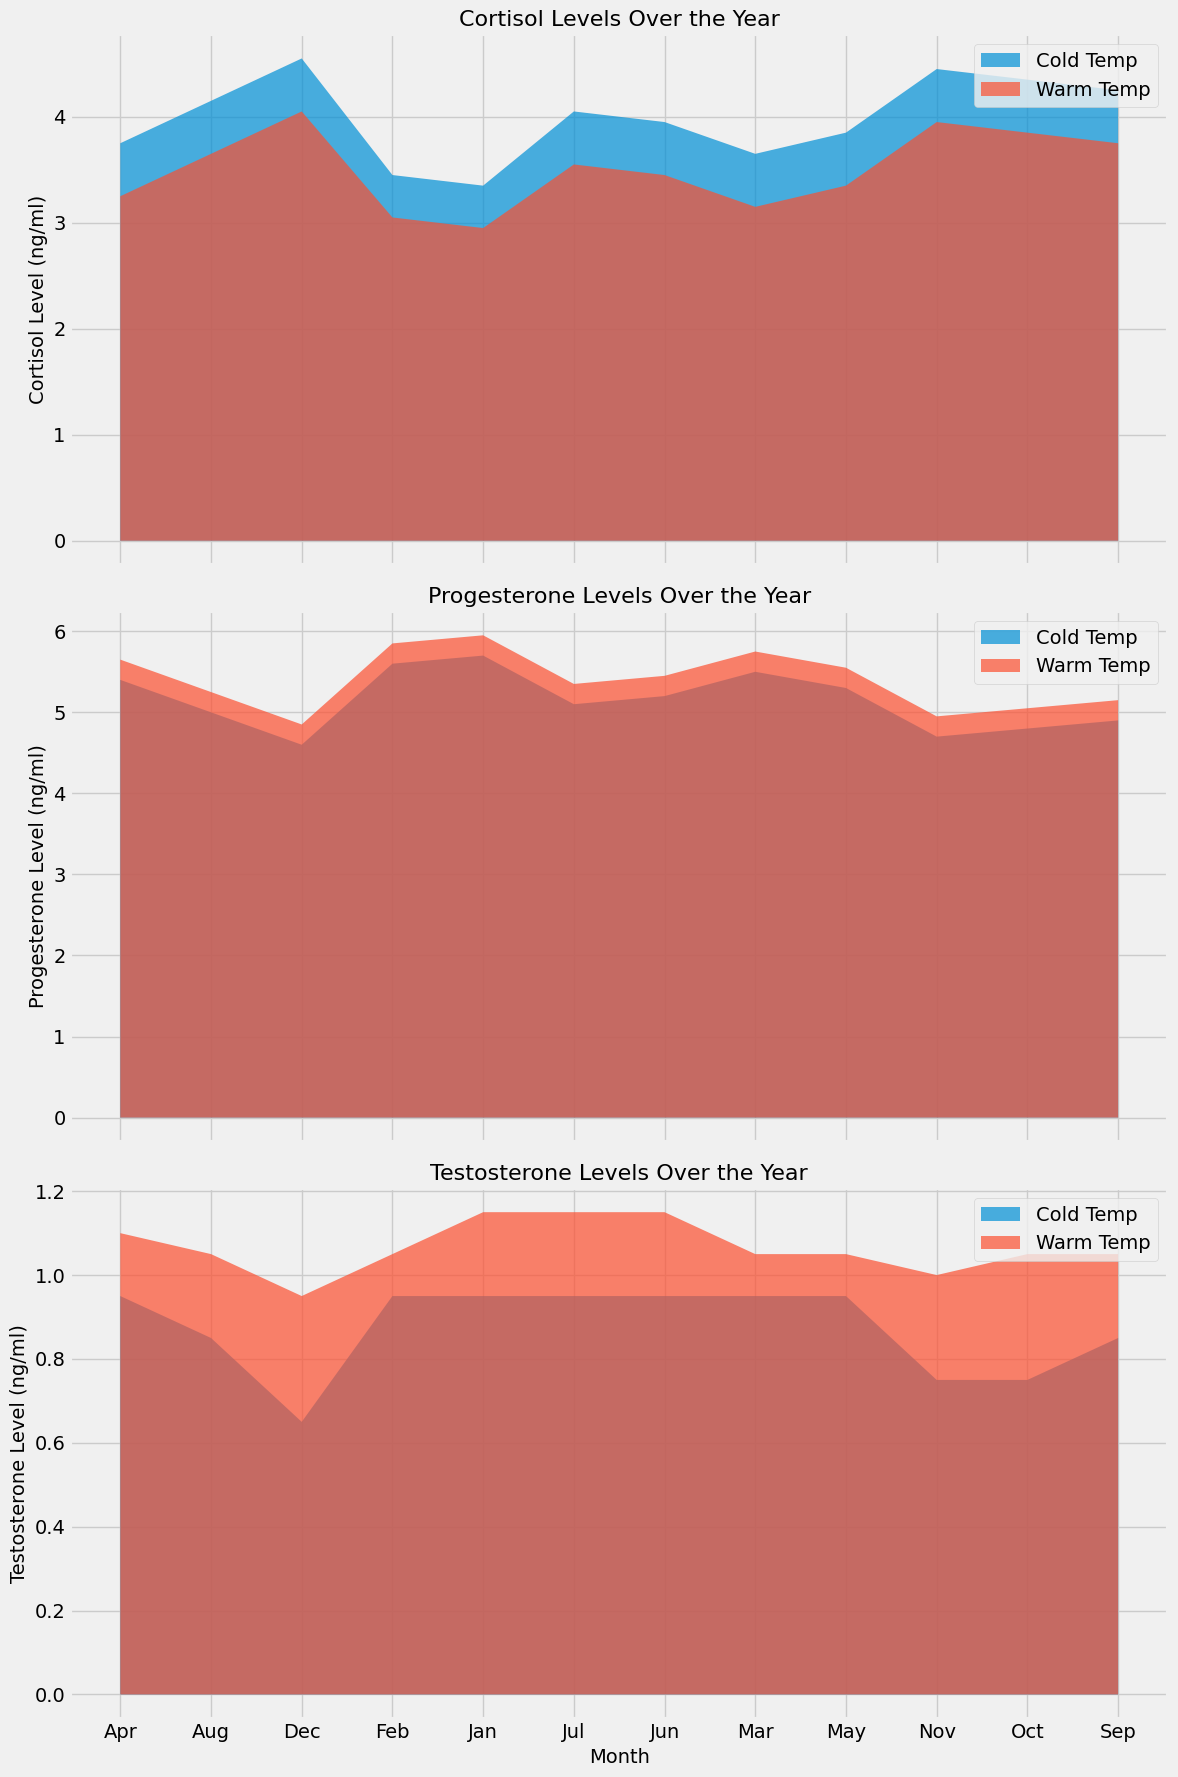Which temperature condition shows the highest average Cortisol Level (ng/ml) in August? To find the highest average Cortisol Level in August, compare the filled areas representing different temperature conditions. The area for "Cold" temperature is higher than that for "Warm" temperature.
Answer: Cold How do Progesterone Levels (ng/ml) change from January to December in high humidity conditions? Compare the filled areas for high humidity under different months. Notice the decrease, especially under "Cold" conditions moving from January to December.
Answer: Decreases What is the trend of Testosterone Levels (ng/ml) under warm temperature conditions throughout the year? Look at the filled area representing warm temperatures for the whole year across the months. The trend shows an initial increase followed by a slight reduction towards the end of the year.
Answer: Increase then decrease In which month do Cortisol Levels (ng/ml) under cold temperature surpass 4.0 ng/ml? Observe the filled area for cold temperatures and look for the month(s) where it crosses the 4.0 ng/ml threshold. This occurs from July through December.
Answer: July to December What is the difference in Progesterone Levels (ng/ml) in "Cold" vs. "Warm" temperatures in June? Identify the height of the filled areas for each temperature condition in June for Progesterone Levels. Subtract the "Warm" level from the "Cold" level. The difference is approximately 5.3 - 5.4 vs. 5.5 - 5.5 = 0.2 ng/ml.
Answer: 0.2 ng/ml Does Testosterone Level (ng/ml) remain constant in high humidity conditions? Observe the filled areas representing high humidity across the year. The Testosterone Levels vary slightly, particularly under different temperature conditions.
Answer: No How does the average Cortisol Level (ng/ml) in September under warm temperatures compare to that under cold temperatures? Compare the filled areas for September under warm and cold temperatures. The Cortisol Level is lower under warm temperatures compared to cold temperatures.
Answer: Lower Which month has the lowest Progesterone Level (ng/ml) under cold temperature and high humidity? Scan through the months looking at the bottom-most point of the filled area for the given conditions. October and December have some of the lowest levels noted.
Answer: October Which hormone shows the most distinct visual difference between "Cold" and "Warm" temperatures? Compare the extent of overlap and non-overlap in the filled areas across the three hormones. Testosterone Levels generally show the most distinct difference throughout the year.
Answer: Testosterone What is the trend of Cortisol Levels (ng/ml) under high humidity as temperature changes from cold to warm? Compare the filled areas for each humidity condition over months, but with separate attention to temperature. Generally, Cortisol Levels are higher under cold temperatures and lower under warm temperatures.
Answer: Decreases 